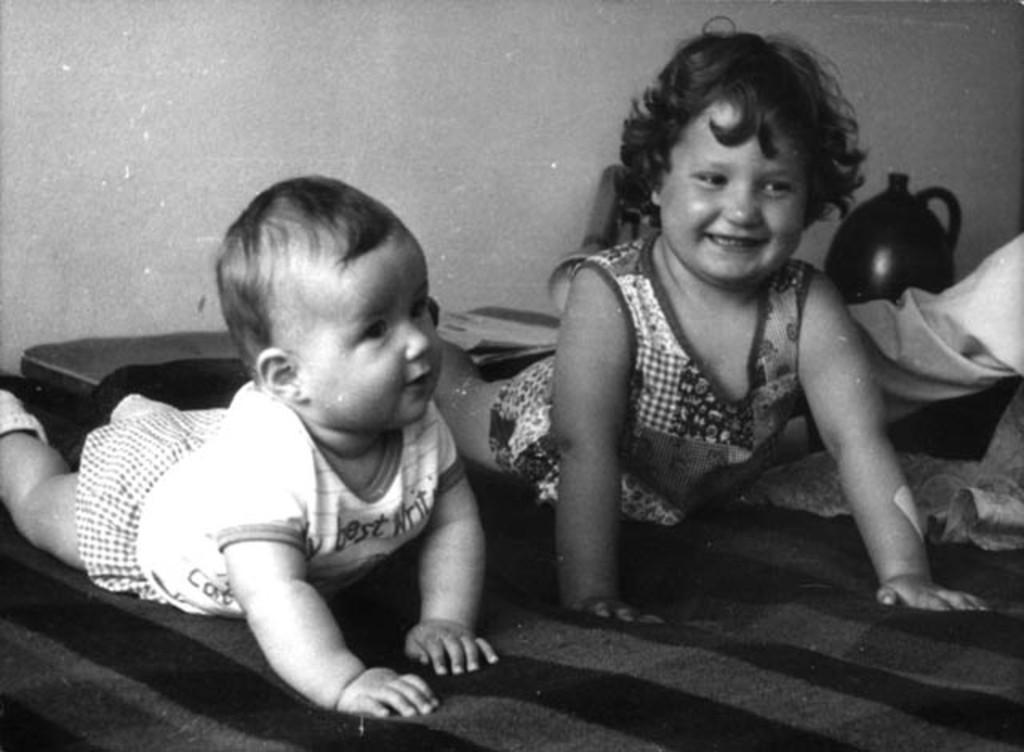In one or two sentences, can you explain what this image depicts? This is a black and white picture. In this picture, we see a baby in white dress and a girl in the frock are lying on the bed. Both of them are smiling. Beside them, we see a table on which lamp and pot are placed. In the background, we see a wall. 